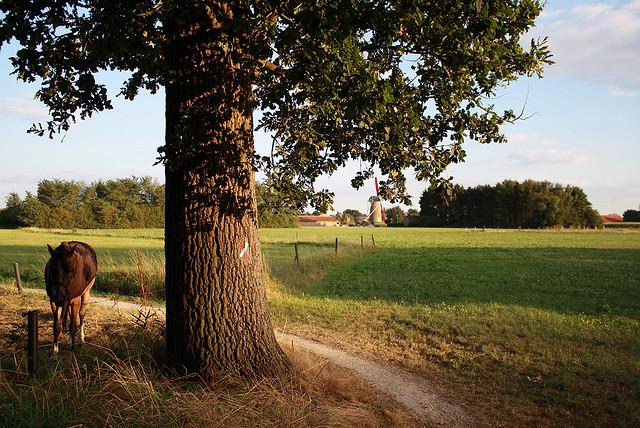Is this a farm?
Write a very short answer. Yes. What animal is under the tree?
Concise answer only. Horse. How tall is the animal?
Short answer required. 5 feet. 